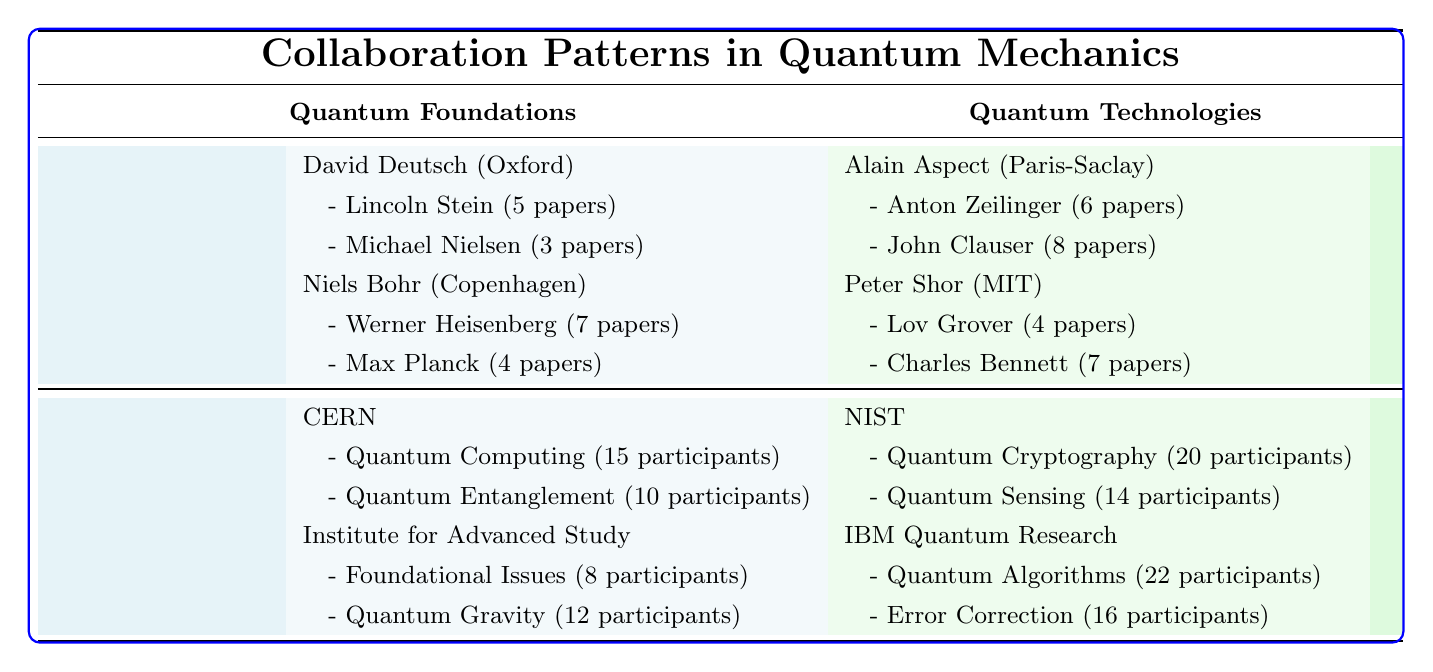What are the total number of papers authored by David Deutsch? David Deutsch has collaborations with Lincoln Stein (5 papers) and Michael Nielsen (3 papers). Summing these gives 5 + 3 = 8 papers.
Answer: 8 Which researcher has the most collaborations listed in the table? Looking at the collaborations per researcher, David Deutsch has 2 collaborations, Niels Bohr has 3 (Werner Heisenberg with 7 papers and Max Planck with 4 papers), Alain Aspect has 2, and Peter Shor has 2. Therefore, Niels Bohr has the most collaborations listed.
Answer: Niels Bohr What is the total number of participants in the Quantum Cryptography project? The Quantum Cryptography project is listed under the National Institute of Standards and Technology with 20 participants.
Answer: 20 Is there any collaborative project at CERN with more than 10 participants? Looking at the collaborative projects at CERN, both the Quantum Computing (15 participants) and Quantum Entanglement Studies (10 participants) have 10 or more participants, confirming that there is at least one project that meets this criterion.
Answer: Yes What is the average number of participants across collaborative projects at IBM Quantum Research? There are two collaborative projects at IBM Quantum Research: Quantum Algorithm Development (22 participants) and Error Correction in Quantum Systems (16 participants). To find the average, sum the participants: 22 + 16 = 38. There are 2 projects, so the average is 38/2 = 19.
Answer: 19 How many papers did Niels Bohr collaborate on in total? Niels Bohr collaborated with Werner Heisenberg (7 papers) and Max Planck (4 papers). Summing those gives 7 + 4 = 11 papers.
Answer: 11 Does Alain Aspect have any joint research collaborations listed? Checking Alain Aspect's collaborations, he has a co-authorship with Anton Zeilinger (6 papers) and a joint research with John Clauser (8 papers). Since a joint research collaboration is included, the answer is affirmative.
Answer: Yes What is the difference in the number of projects between CERN and the Institute for Advanced Study? Both CERN and the Institute for Advanced Study have 2 collaborative projects listed. Therefore, the difference in the number of projects is 2 - 2 = 0.
Answer: 0 Which institution has the largest number of participants in its collaborative projects? Looking at the collaborative projects, IBM Quantum Research has the Quantum Algorithm Development project with 22 participants, which is the largest number compared to other institutions listed.
Answer: IBM Quantum Research What is the combined total of papers authored by Peter Shor and Niels Bohr? Peter Shor has 4 papers (with Lov Grover) and 7 papers (with Charles Bennett), and Niels Bohr has 7 papers (with Werner Heisenberg) and 4 papers (with Max Planck). Summing Peter Shor's papers gives 4 + 7 = 11, and Niels Bohr's gives 7 + 4 = 11. The combined total is 11 + 11 = 22 papers.
Answer: 22 